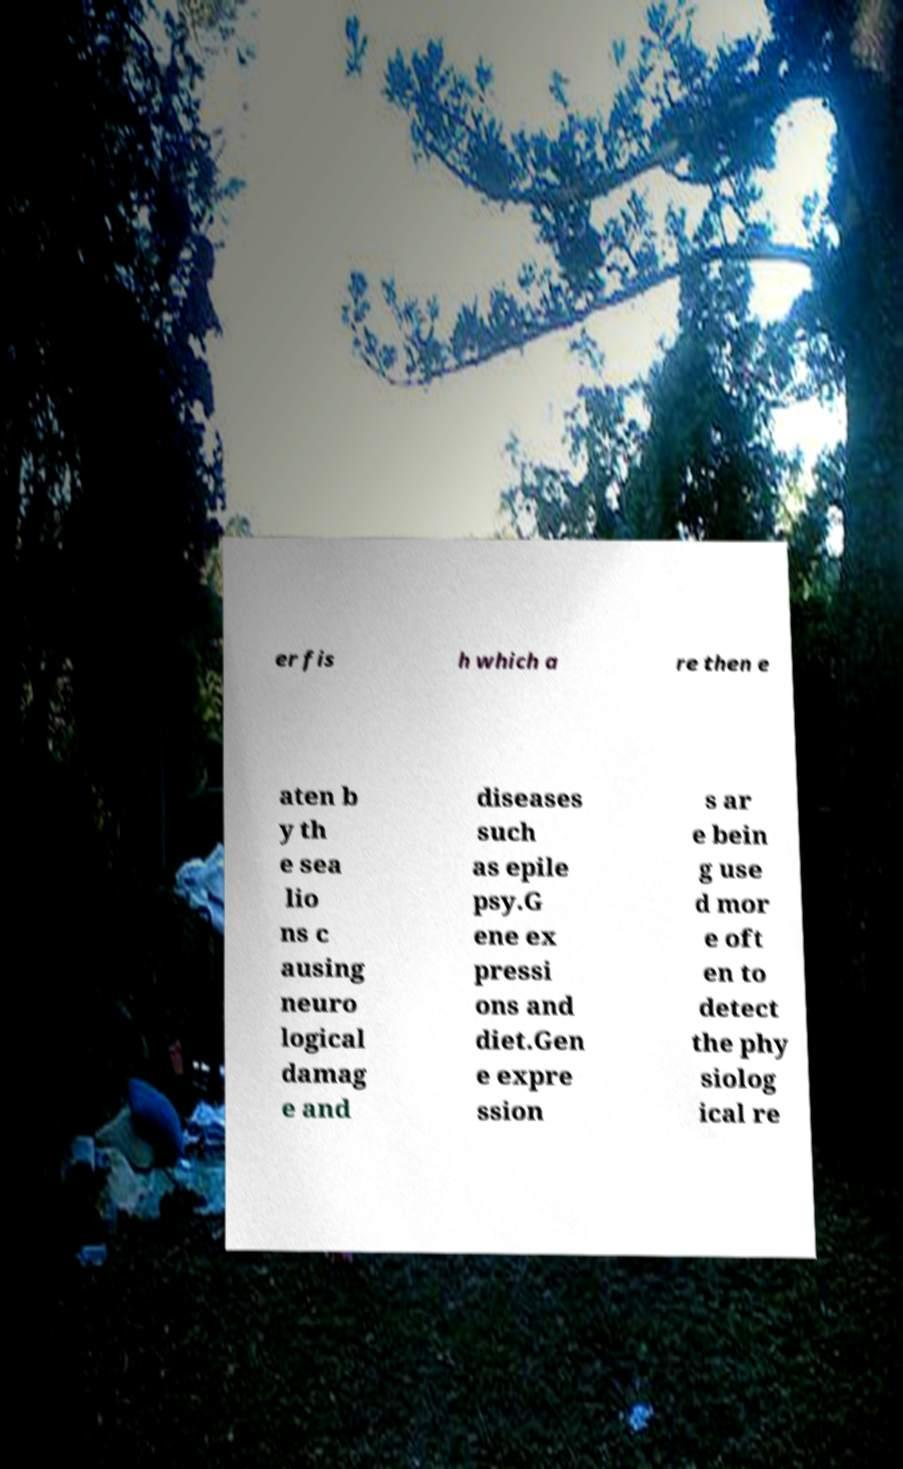Could you extract and type out the text from this image? er fis h which a re then e aten b y th e sea lio ns c ausing neuro logical damag e and diseases such as epile psy.G ene ex pressi ons and diet.Gen e expre ssion s ar e bein g use d mor e oft en to detect the phy siolog ical re 